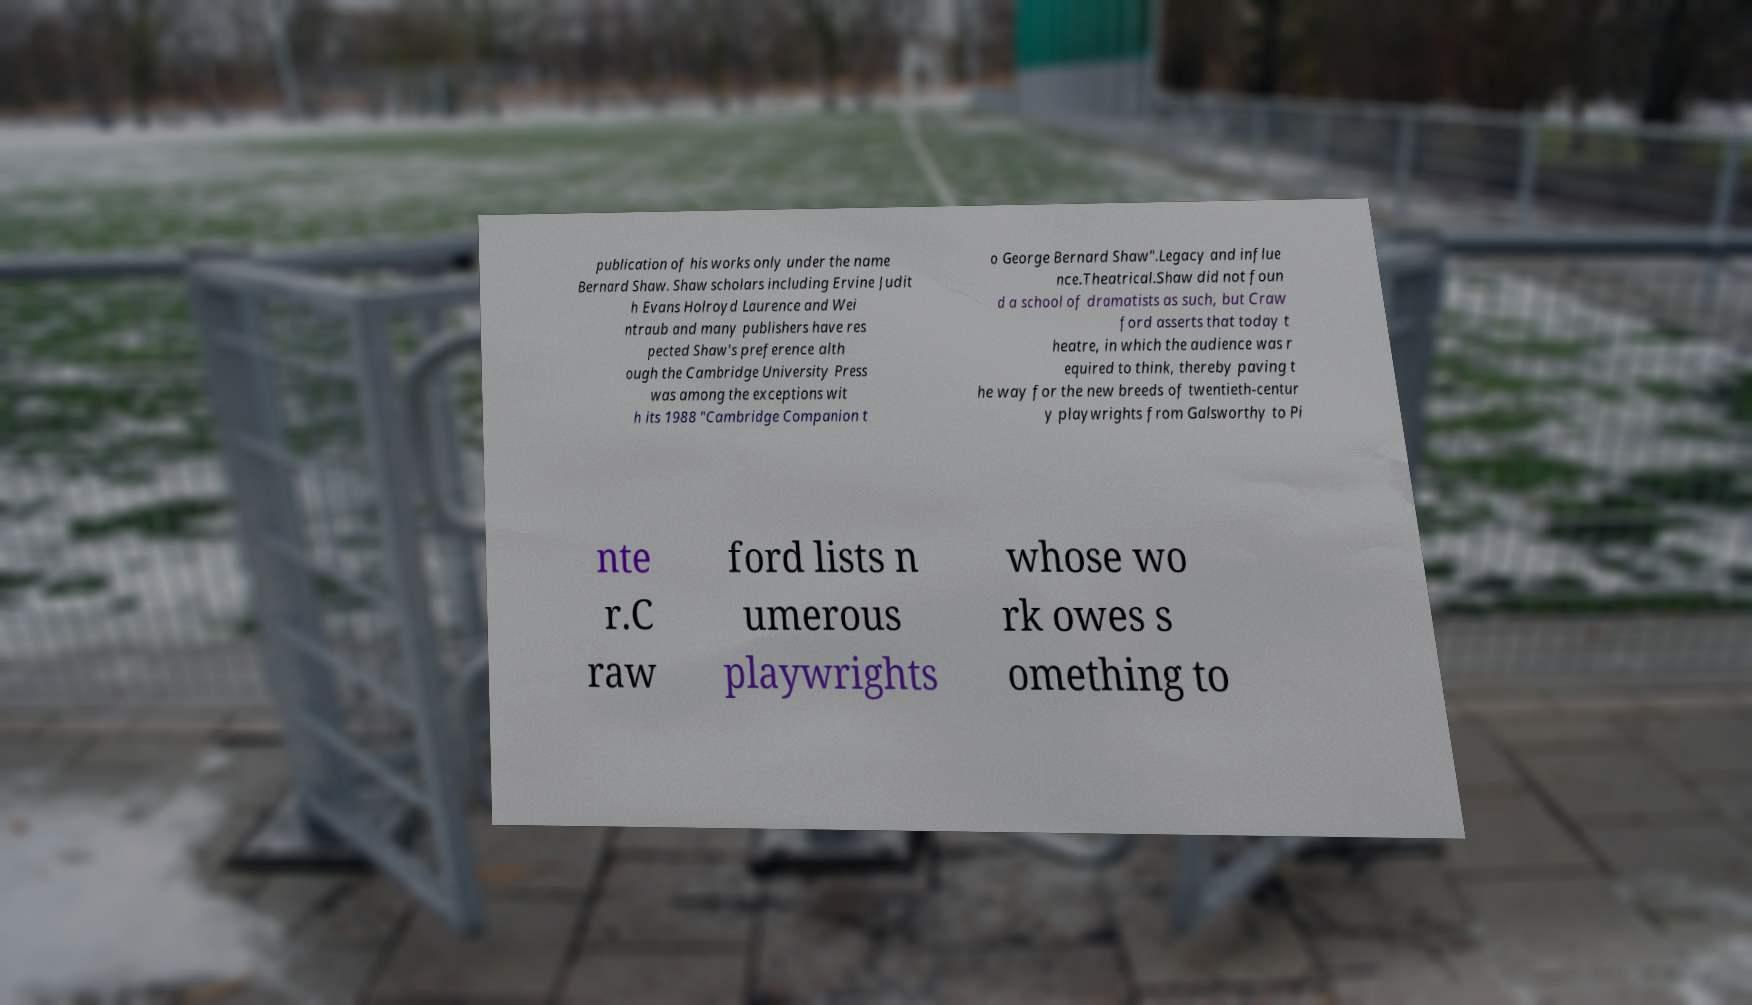Please identify and transcribe the text found in this image. publication of his works only under the name Bernard Shaw. Shaw scholars including Ervine Judit h Evans Holroyd Laurence and Wei ntraub and many publishers have res pected Shaw's preference alth ough the Cambridge University Press was among the exceptions wit h its 1988 "Cambridge Companion t o George Bernard Shaw".Legacy and influe nce.Theatrical.Shaw did not foun d a school of dramatists as such, but Craw ford asserts that today t heatre, in which the audience was r equired to think, thereby paving t he way for the new breeds of twentieth-centur y playwrights from Galsworthy to Pi nte r.C raw ford lists n umerous playwrights whose wo rk owes s omething to 